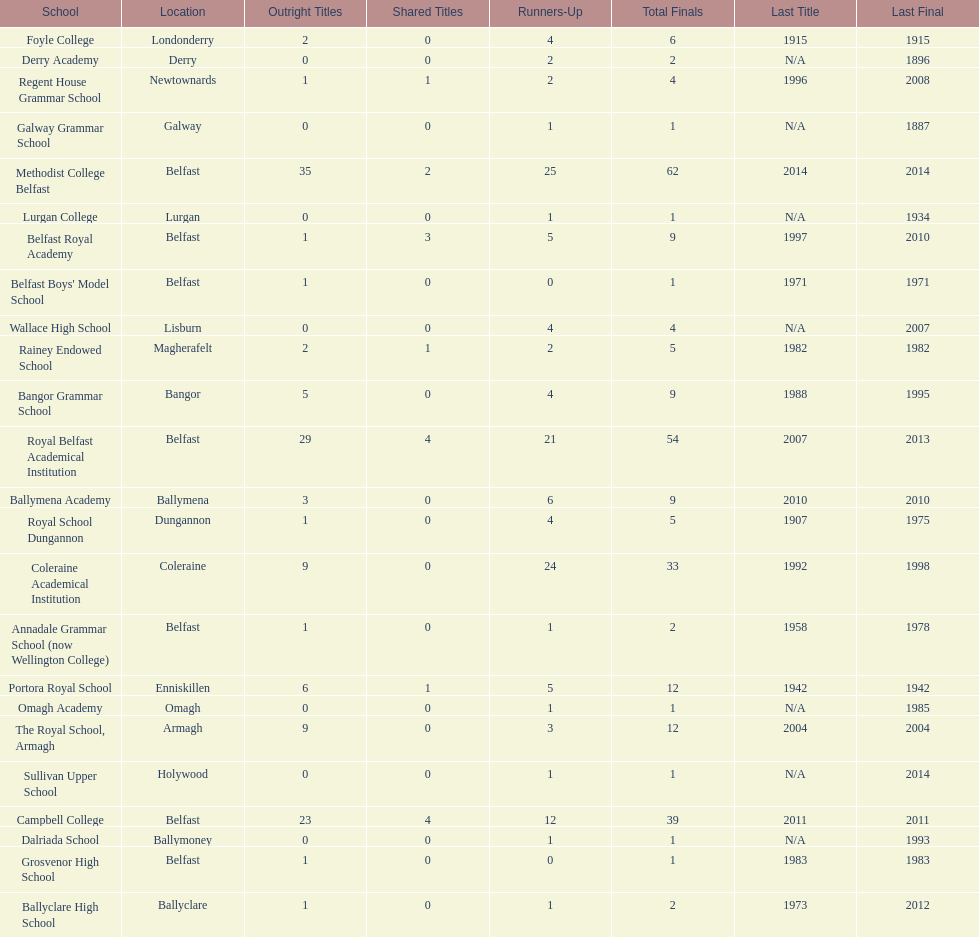I'm looking to parse the entire table for insights. Could you assist me with that? {'header': ['School', 'Location', 'Outright Titles', 'Shared Titles', 'Runners-Up', 'Total Finals', 'Last Title', 'Last Final'], 'rows': [['Foyle College', 'Londonderry', '2', '0', '4', '6', '1915', '1915'], ['Derry Academy', 'Derry', '0', '0', '2', '2', 'N/A', '1896'], ['Regent House Grammar School', 'Newtownards', '1', '1', '2', '4', '1996', '2008'], ['Galway Grammar School', 'Galway', '0', '0', '1', '1', 'N/A', '1887'], ['Methodist College Belfast', 'Belfast', '35', '2', '25', '62', '2014', '2014'], ['Lurgan College', 'Lurgan', '0', '0', '1', '1', 'N/A', '1934'], ['Belfast Royal Academy', 'Belfast', '1', '3', '5', '9', '1997', '2010'], ["Belfast Boys' Model School", 'Belfast', '1', '0', '0', '1', '1971', '1971'], ['Wallace High School', 'Lisburn', '0', '0', '4', '4', 'N/A', '2007'], ['Rainey Endowed School', 'Magherafelt', '2', '1', '2', '5', '1982', '1982'], ['Bangor Grammar School', 'Bangor', '5', '0', '4', '9', '1988', '1995'], ['Royal Belfast Academical Institution', 'Belfast', '29', '4', '21', '54', '2007', '2013'], ['Ballymena Academy', 'Ballymena', '3', '0', '6', '9', '2010', '2010'], ['Royal School Dungannon', 'Dungannon', '1', '0', '4', '5', '1907', '1975'], ['Coleraine Academical Institution', 'Coleraine', '9', '0', '24', '33', '1992', '1998'], ['Annadale Grammar School (now Wellington College)', 'Belfast', '1', '0', '1', '2', '1958', '1978'], ['Portora Royal School', 'Enniskillen', '6', '1', '5', '12', '1942', '1942'], ['Omagh Academy', 'Omagh', '0', '0', '1', '1', 'N/A', '1985'], ['The Royal School, Armagh', 'Armagh', '9', '0', '3', '12', '2004', '2004'], ['Sullivan Upper School', 'Holywood', '0', '0', '1', '1', 'N/A', '2014'], ['Campbell College', 'Belfast', '23', '4', '12', '39', '2011', '2011'], ['Dalriada School', 'Ballymoney', '0', '0', '1', '1', 'N/A', '1993'], ['Grosvenor High School', 'Belfast', '1', '0', '0', '1', '1983', '1983'], ['Ballyclare High School', 'Ballyclare', '1', '0', '1', '2', '1973', '2012']]} Who has the most recent title win, campbell college or regent house grammar school? Campbell College. 